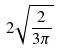Convert formula to latex. <formula><loc_0><loc_0><loc_500><loc_500>2 \sqrt { \frac { 2 } { 3 \pi } }</formula> 